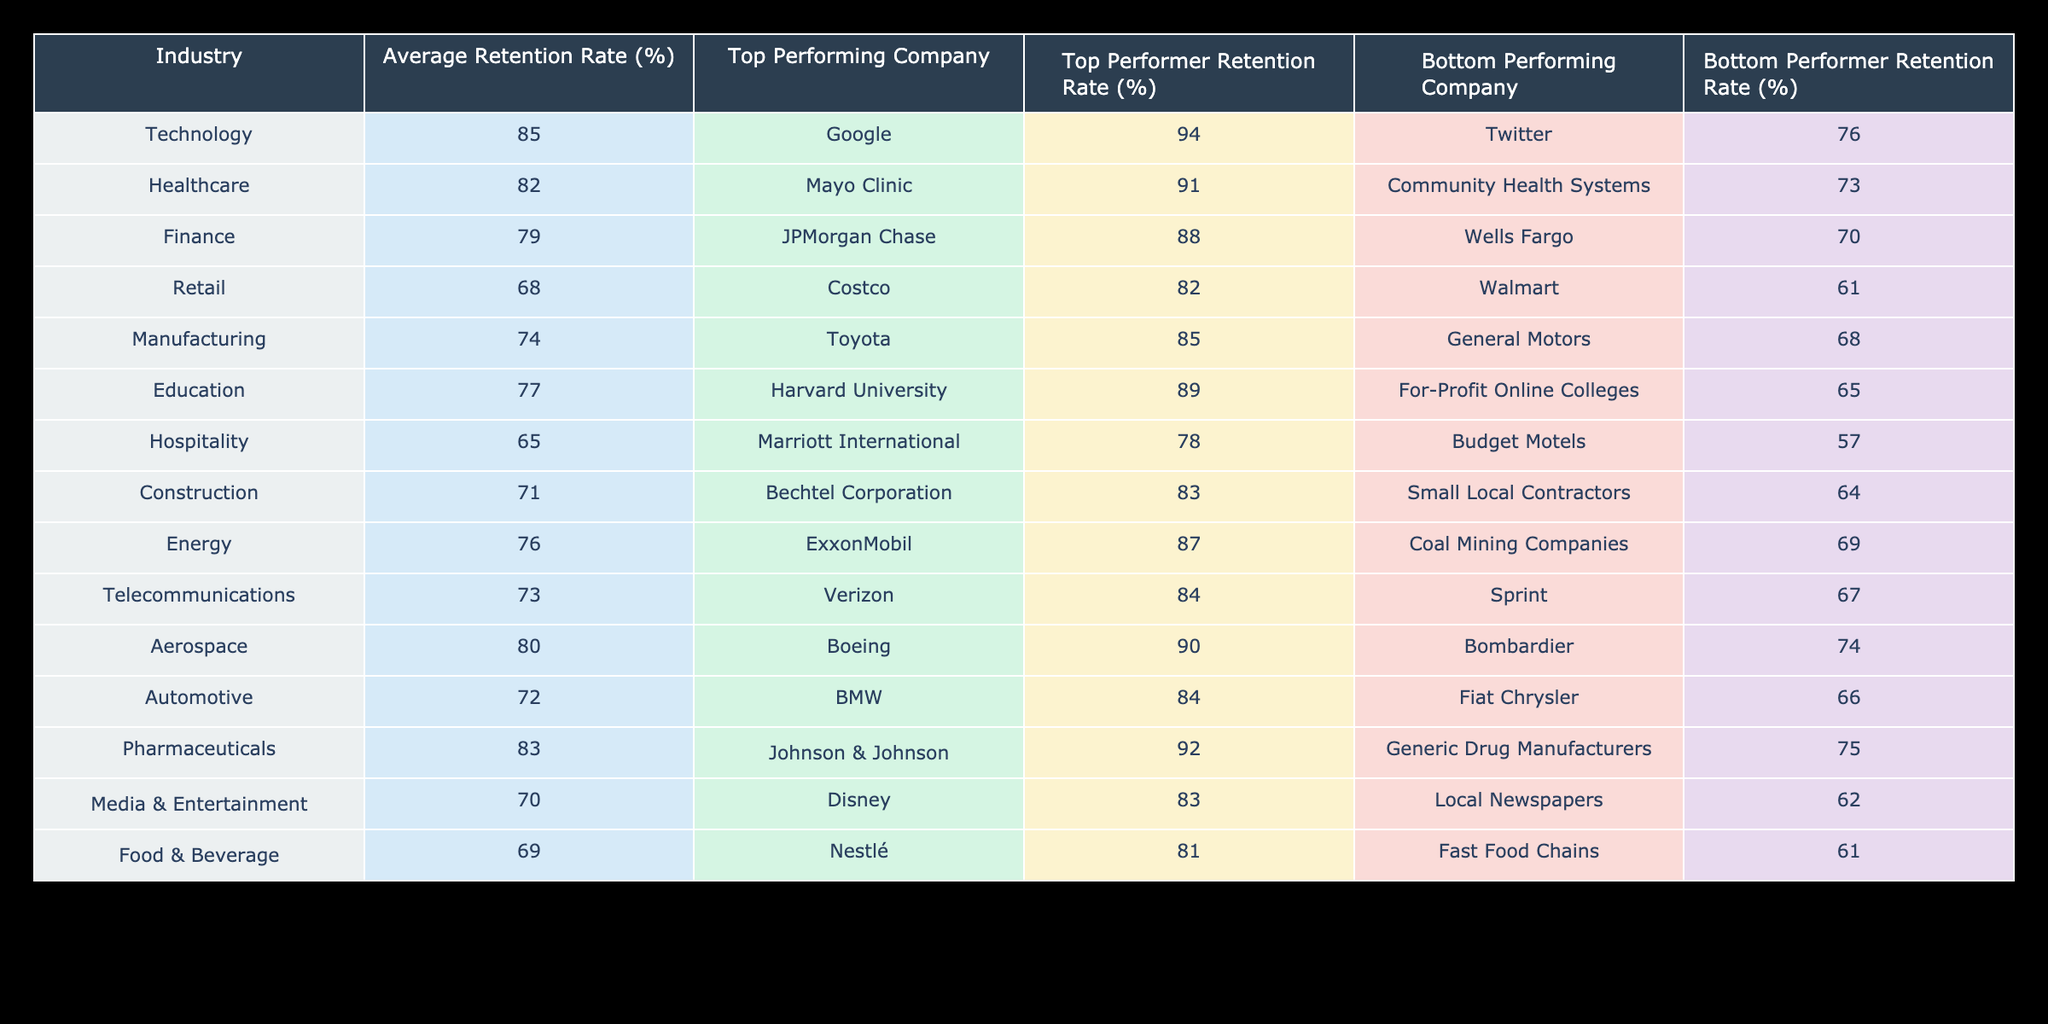What is the average retention rate for the Healthcare industry? The table lists the average retention rate for the Healthcare industry as 82%.
Answer: 82% Which industry has the lowest average retention rate? The Retail industry has the lowest average retention rate at 68%.
Answer: Retail Is it true that the top-performing company in the Automotive industry has a retention rate higher than the average retention rate of the Finance industry? The top-performing company in the Automotive industry is BMW with a retention rate of 84%, while the average retention rate of the Finance industry is 79%. Since 84% is greater than 79%, the statement is true.
Answer: Yes What is the difference in retention rates between the top-performing company and the bottom-performing company in the Pharmaceutical industry? The top-performing company, Johnson & Johnson, has a retention rate of 92%, and the bottom-performing company has a rate of 75%. The difference is 92% - 75% = 17%.
Answer: 17% Which company in the Telecommunications industry has a retention rate above 80%? Verizon is the top-performing company in the Telecommunications industry with a retention rate of 84%.
Answer: Verizon What is the average retention rate for the Education and Hospitality industries combined? The average retention rate for the Education industry is 77%, and for the Hospitality industry, it is 65%. To find the combined average: (77% + 65%) / 2 = 71%.
Answer: 71% Which industry shows a higher average retention rate: Energy or Telecommunications? The average retention rate for the Energy industry is 76%, while for Telecommunications, it is 73%. Since 76% is greater than 73%, Energy shows a higher average retention rate.
Answer: Energy How many industries have an average retention rate of 80% or higher? The industries with an average retention rate of 80% or higher are Technology (85%), Healthcare (82%), Pharmaceuticals (83%), and Aerospace (80%). That totals 4 industries.
Answer: 4 Which bottom-performing company in the Construction industry has the highest retention rate? Small Local Contractors is the bottom-performing company in the Construction industry with a retention rate of 64%. There is no other bottom-performing company in this industry to compare, so 64% is the highest.
Answer: 64% 